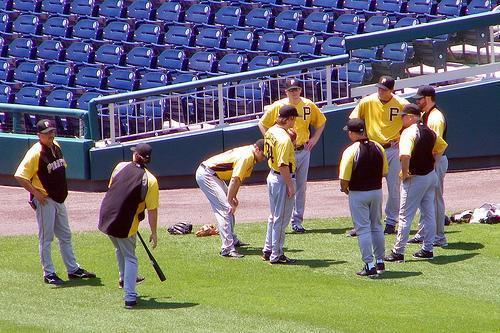How many people are there?
Give a very brief answer. 9. How many baseball bats are there?
Give a very brief answer. 1. How many people are holding a bat?
Give a very brief answer. 1. 